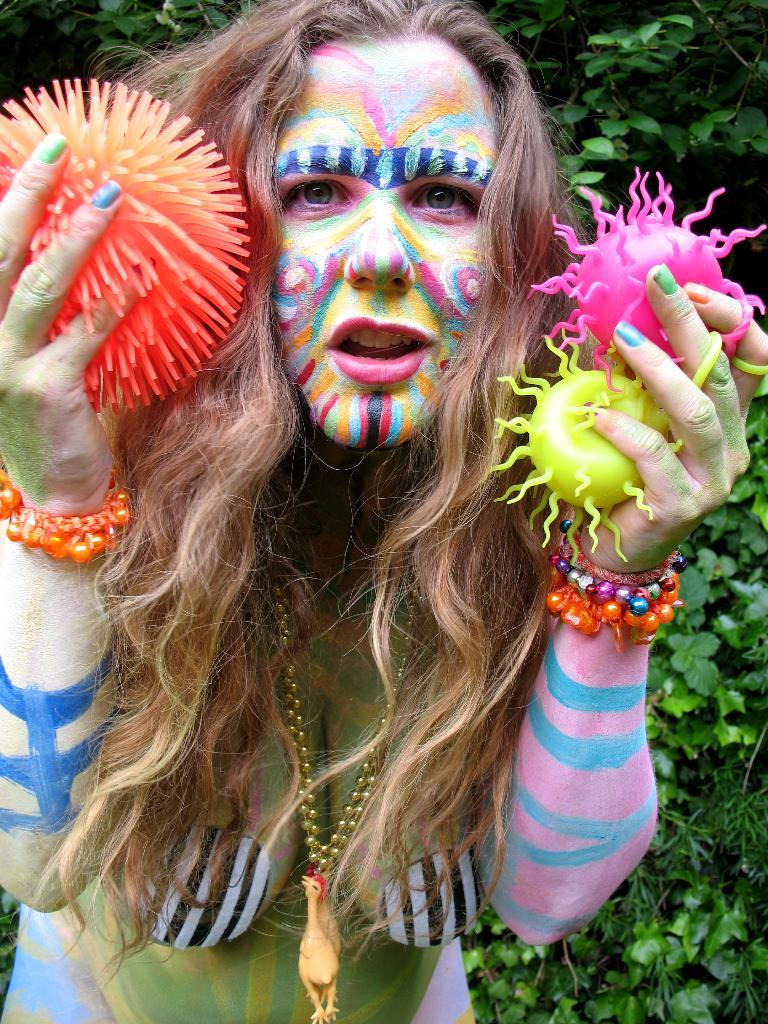Who is the main subject in the image? There is a woman in the image. What is unique about the woman's appearance? The woman has a painting on her. What is the woman holding in her hands? The woman is holding objects in her hands. What can be seen in the background of the image? There are trees in the background of the image. What type of light can be seen shining on the woman in the image? There is no specific light source mentioned in the image, so it cannot be determined what type of light is shining on the woman. 